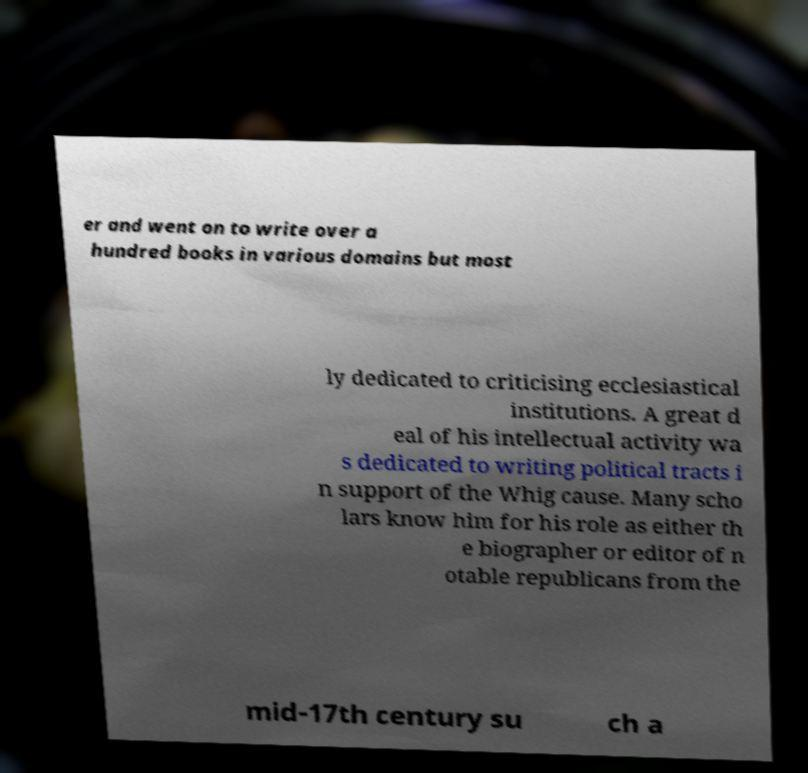Please read and relay the text visible in this image. What does it say? er and went on to write over a hundred books in various domains but most ly dedicated to criticising ecclesiastical institutions. A great d eal of his intellectual activity wa s dedicated to writing political tracts i n support of the Whig cause. Many scho lars know him for his role as either th e biographer or editor of n otable republicans from the mid-17th century su ch a 